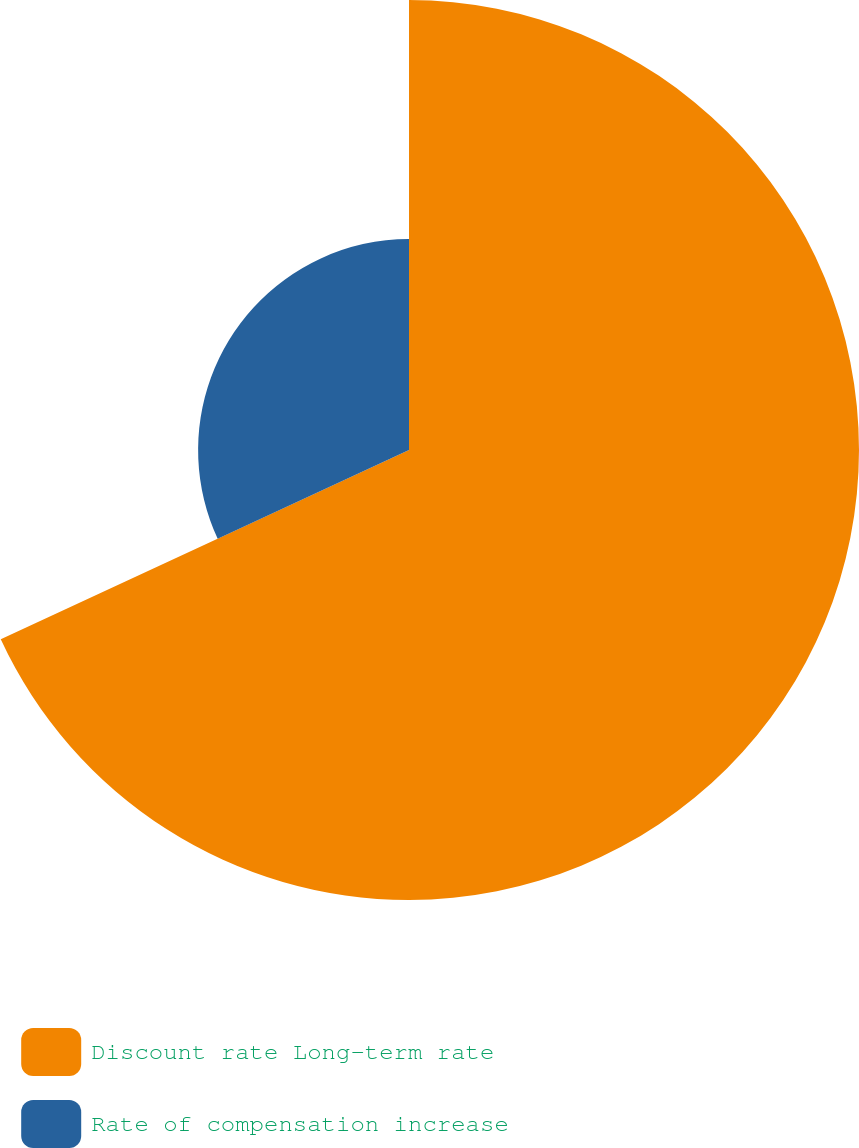Convert chart. <chart><loc_0><loc_0><loc_500><loc_500><pie_chart><fcel>Discount rate Long-term rate<fcel>Rate of compensation increase<nl><fcel>68.09%<fcel>31.91%<nl></chart> 